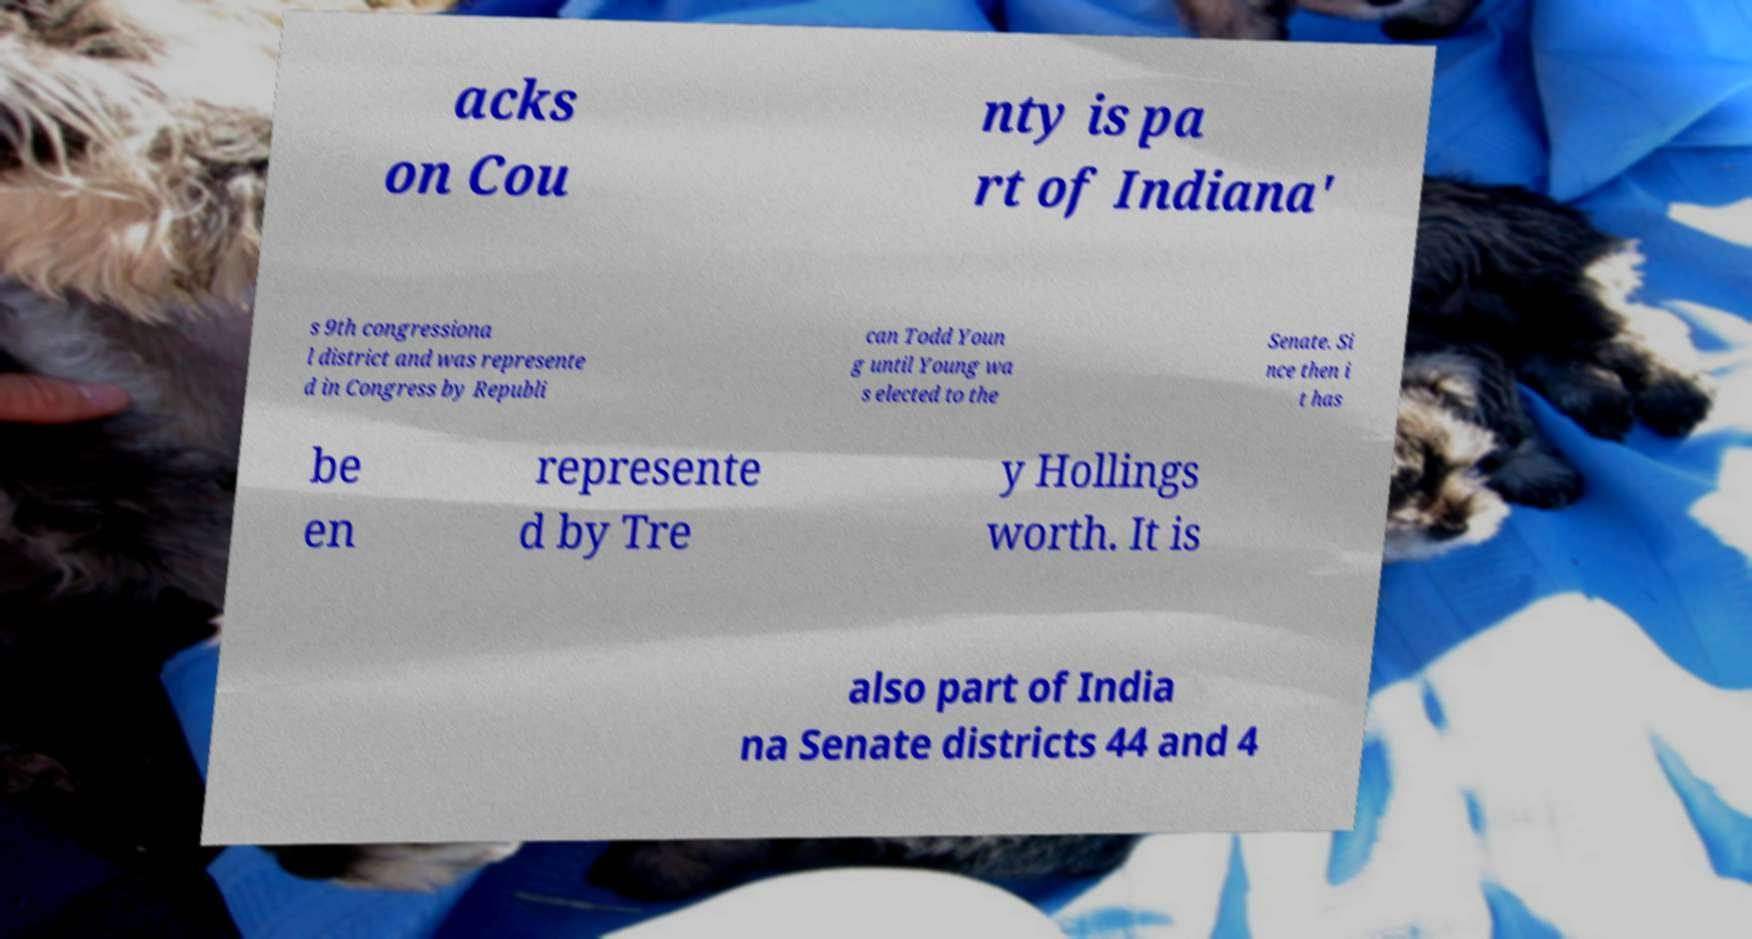Please read and relay the text visible in this image. What does it say? acks on Cou nty is pa rt of Indiana' s 9th congressiona l district and was represente d in Congress by Republi can Todd Youn g until Young wa s elected to the Senate. Si nce then i t has be en represente d by Tre y Hollings worth. It is also part of India na Senate districts 44 and 4 